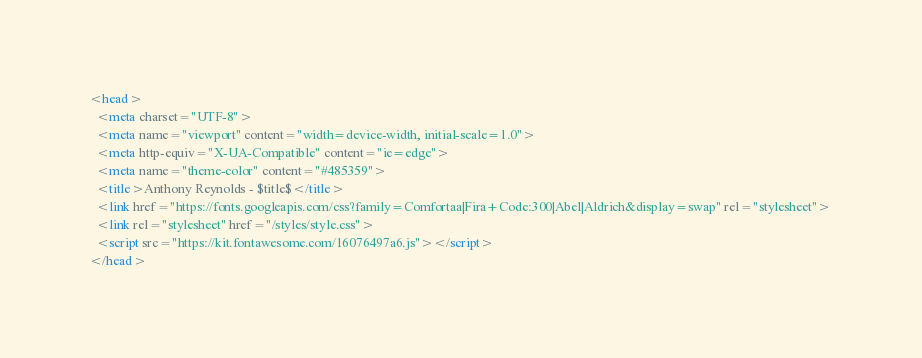<code> <loc_0><loc_0><loc_500><loc_500><_HTML_><head>
  <meta charset="UTF-8">
  <meta name="viewport" content="width=device-width, initial-scale=1.0">
  <meta http-equiv="X-UA-Compatible" content="ie=edge">
  <meta name="theme-color" content="#485359">
  <title>Anthony Reynolds - $title$</title>
  <link href="https://fonts.googleapis.com/css?family=Comfortaa|Fira+Code:300|Abel|Aldrich&display=swap" rel="stylesheet"> 
  <link rel="stylesheet" href="/styles/style.css">
  <script src="https://kit.fontawesome.com/16076497a6.js"></script>
</head></code> 